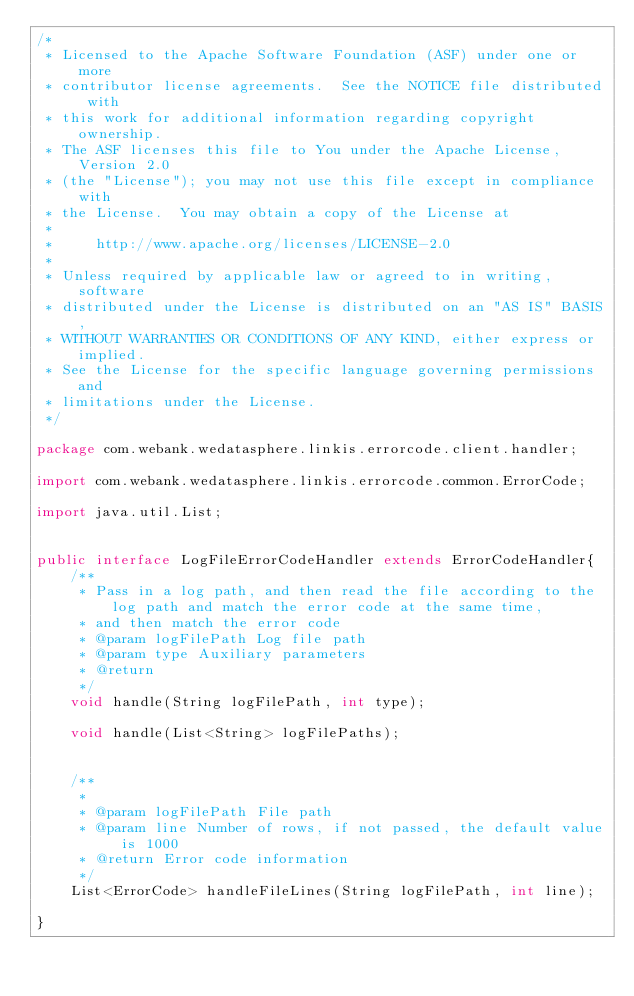<code> <loc_0><loc_0><loc_500><loc_500><_Java_>/*
 * Licensed to the Apache Software Foundation (ASF) under one or more
 * contributor license agreements.  See the NOTICE file distributed with
 * this work for additional information regarding copyright ownership.
 * The ASF licenses this file to You under the Apache License, Version 2.0
 * (the "License"); you may not use this file except in compliance with
 * the License.  You may obtain a copy of the License at
 *
 *     http://www.apache.org/licenses/LICENSE-2.0
 *
 * Unless required by applicable law or agreed to in writing, software
 * distributed under the License is distributed on an "AS IS" BASIS,
 * WITHOUT WARRANTIES OR CONDITIONS OF ANY KIND, either express or implied.
 * See the License for the specific language governing permissions and
 * limitations under the License.
 */

package com.webank.wedatasphere.linkis.errorcode.client.handler;

import com.webank.wedatasphere.linkis.errorcode.common.ErrorCode;

import java.util.List;


public interface LogFileErrorCodeHandler extends ErrorCodeHandler{
    /**
     * Pass in a log path, and then read the file according to the log path and match the error code at the same time,
     * and then match the error code
     * @param logFilePath Log file path
     * @param type Auxiliary parameters
     * @return
     */
    void handle(String logFilePath, int type);

    void handle(List<String> logFilePaths);


    /**
     *
     * @param logFilePath File path
     * @param line Number of rows, if not passed, the default value is 1000
     * @return Error code information
     */
    List<ErrorCode> handleFileLines(String logFilePath, int line);

}
</code> 